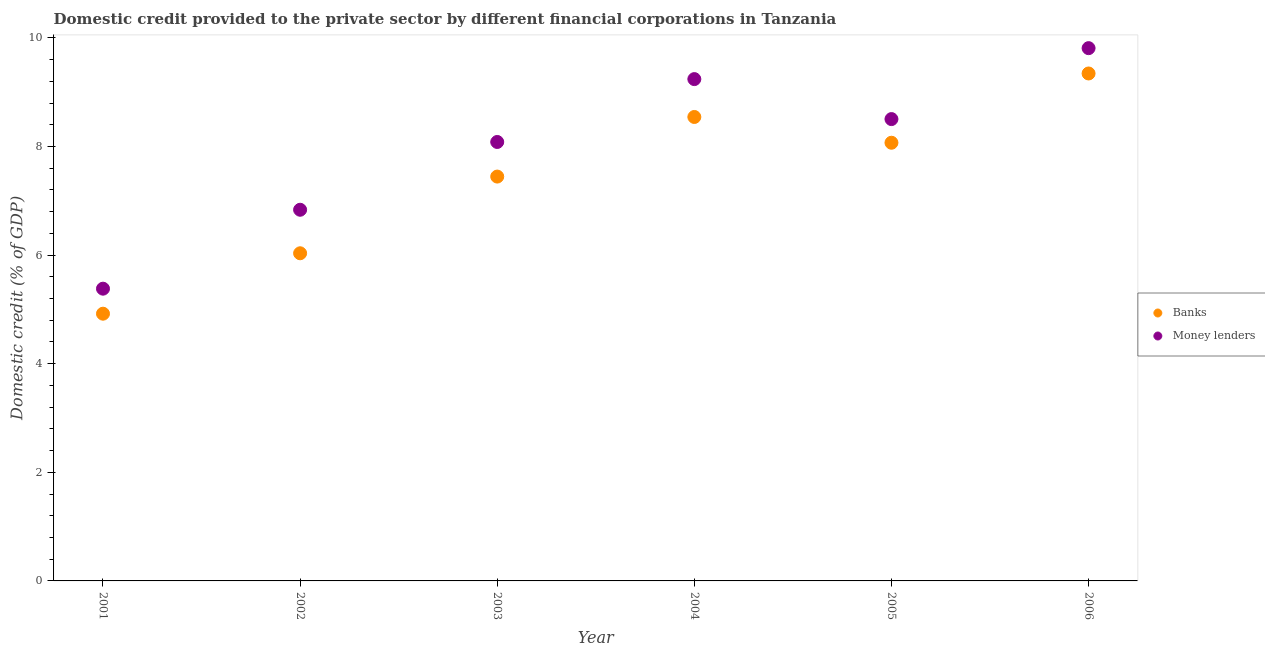What is the domestic credit provided by money lenders in 2001?
Provide a short and direct response. 5.38. Across all years, what is the maximum domestic credit provided by money lenders?
Your response must be concise. 9.81. Across all years, what is the minimum domestic credit provided by money lenders?
Your answer should be compact. 5.38. In which year was the domestic credit provided by banks maximum?
Provide a succinct answer. 2006. In which year was the domestic credit provided by banks minimum?
Provide a succinct answer. 2001. What is the total domestic credit provided by money lenders in the graph?
Give a very brief answer. 47.85. What is the difference between the domestic credit provided by banks in 2001 and that in 2002?
Your answer should be compact. -1.11. What is the difference between the domestic credit provided by money lenders in 2006 and the domestic credit provided by banks in 2005?
Your response must be concise. 1.74. What is the average domestic credit provided by money lenders per year?
Your answer should be compact. 7.98. In the year 2006, what is the difference between the domestic credit provided by banks and domestic credit provided by money lenders?
Offer a very short reply. -0.47. What is the ratio of the domestic credit provided by banks in 2004 to that in 2005?
Offer a very short reply. 1.06. What is the difference between the highest and the second highest domestic credit provided by banks?
Ensure brevity in your answer.  0.8. What is the difference between the highest and the lowest domestic credit provided by banks?
Your answer should be very brief. 4.42. In how many years, is the domestic credit provided by banks greater than the average domestic credit provided by banks taken over all years?
Offer a terse response. 4. Is the sum of the domestic credit provided by money lenders in 2002 and 2003 greater than the maximum domestic credit provided by banks across all years?
Provide a succinct answer. Yes. Does the domestic credit provided by banks monotonically increase over the years?
Offer a very short reply. No. Is the domestic credit provided by money lenders strictly greater than the domestic credit provided by banks over the years?
Your response must be concise. Yes. Are the values on the major ticks of Y-axis written in scientific E-notation?
Provide a short and direct response. No. Does the graph contain any zero values?
Offer a very short reply. No. What is the title of the graph?
Give a very brief answer. Domestic credit provided to the private sector by different financial corporations in Tanzania. What is the label or title of the Y-axis?
Provide a succinct answer. Domestic credit (% of GDP). What is the Domestic credit (% of GDP) of Banks in 2001?
Give a very brief answer. 4.92. What is the Domestic credit (% of GDP) of Money lenders in 2001?
Offer a terse response. 5.38. What is the Domestic credit (% of GDP) in Banks in 2002?
Make the answer very short. 6.03. What is the Domestic credit (% of GDP) in Money lenders in 2002?
Your answer should be compact. 6.83. What is the Domestic credit (% of GDP) of Banks in 2003?
Give a very brief answer. 7.45. What is the Domestic credit (% of GDP) in Money lenders in 2003?
Offer a terse response. 8.08. What is the Domestic credit (% of GDP) of Banks in 2004?
Provide a succinct answer. 8.54. What is the Domestic credit (% of GDP) in Money lenders in 2004?
Keep it short and to the point. 9.24. What is the Domestic credit (% of GDP) of Banks in 2005?
Your response must be concise. 8.07. What is the Domestic credit (% of GDP) in Money lenders in 2005?
Provide a short and direct response. 8.5. What is the Domestic credit (% of GDP) in Banks in 2006?
Your response must be concise. 9.34. What is the Domestic credit (% of GDP) of Money lenders in 2006?
Make the answer very short. 9.81. Across all years, what is the maximum Domestic credit (% of GDP) in Banks?
Provide a succinct answer. 9.34. Across all years, what is the maximum Domestic credit (% of GDP) in Money lenders?
Ensure brevity in your answer.  9.81. Across all years, what is the minimum Domestic credit (% of GDP) of Banks?
Your answer should be compact. 4.92. Across all years, what is the minimum Domestic credit (% of GDP) in Money lenders?
Provide a succinct answer. 5.38. What is the total Domestic credit (% of GDP) of Banks in the graph?
Offer a terse response. 44.36. What is the total Domestic credit (% of GDP) in Money lenders in the graph?
Offer a very short reply. 47.85. What is the difference between the Domestic credit (% of GDP) of Banks in 2001 and that in 2002?
Your answer should be compact. -1.11. What is the difference between the Domestic credit (% of GDP) of Money lenders in 2001 and that in 2002?
Offer a very short reply. -1.45. What is the difference between the Domestic credit (% of GDP) in Banks in 2001 and that in 2003?
Offer a very short reply. -2.52. What is the difference between the Domestic credit (% of GDP) in Money lenders in 2001 and that in 2003?
Your answer should be compact. -2.7. What is the difference between the Domestic credit (% of GDP) in Banks in 2001 and that in 2004?
Offer a terse response. -3.62. What is the difference between the Domestic credit (% of GDP) of Money lenders in 2001 and that in 2004?
Keep it short and to the point. -3.86. What is the difference between the Domestic credit (% of GDP) of Banks in 2001 and that in 2005?
Your answer should be very brief. -3.15. What is the difference between the Domestic credit (% of GDP) of Money lenders in 2001 and that in 2005?
Make the answer very short. -3.12. What is the difference between the Domestic credit (% of GDP) in Banks in 2001 and that in 2006?
Provide a short and direct response. -4.42. What is the difference between the Domestic credit (% of GDP) of Money lenders in 2001 and that in 2006?
Your answer should be very brief. -4.43. What is the difference between the Domestic credit (% of GDP) in Banks in 2002 and that in 2003?
Provide a succinct answer. -1.41. What is the difference between the Domestic credit (% of GDP) in Money lenders in 2002 and that in 2003?
Give a very brief answer. -1.25. What is the difference between the Domestic credit (% of GDP) in Banks in 2002 and that in 2004?
Your response must be concise. -2.51. What is the difference between the Domestic credit (% of GDP) of Money lenders in 2002 and that in 2004?
Make the answer very short. -2.41. What is the difference between the Domestic credit (% of GDP) in Banks in 2002 and that in 2005?
Keep it short and to the point. -2.04. What is the difference between the Domestic credit (% of GDP) in Money lenders in 2002 and that in 2005?
Offer a terse response. -1.67. What is the difference between the Domestic credit (% of GDP) of Banks in 2002 and that in 2006?
Your answer should be compact. -3.31. What is the difference between the Domestic credit (% of GDP) in Money lenders in 2002 and that in 2006?
Offer a terse response. -2.98. What is the difference between the Domestic credit (% of GDP) in Banks in 2003 and that in 2004?
Provide a short and direct response. -1.1. What is the difference between the Domestic credit (% of GDP) of Money lenders in 2003 and that in 2004?
Provide a short and direct response. -1.16. What is the difference between the Domestic credit (% of GDP) of Banks in 2003 and that in 2005?
Offer a very short reply. -0.62. What is the difference between the Domestic credit (% of GDP) of Money lenders in 2003 and that in 2005?
Your answer should be very brief. -0.42. What is the difference between the Domestic credit (% of GDP) of Banks in 2003 and that in 2006?
Your answer should be compact. -1.9. What is the difference between the Domestic credit (% of GDP) in Money lenders in 2003 and that in 2006?
Your response must be concise. -1.73. What is the difference between the Domestic credit (% of GDP) in Banks in 2004 and that in 2005?
Your answer should be compact. 0.47. What is the difference between the Domestic credit (% of GDP) in Money lenders in 2004 and that in 2005?
Your answer should be very brief. 0.74. What is the difference between the Domestic credit (% of GDP) of Banks in 2004 and that in 2006?
Provide a succinct answer. -0.8. What is the difference between the Domestic credit (% of GDP) in Money lenders in 2004 and that in 2006?
Your answer should be very brief. -0.57. What is the difference between the Domestic credit (% of GDP) of Banks in 2005 and that in 2006?
Your answer should be compact. -1.28. What is the difference between the Domestic credit (% of GDP) in Money lenders in 2005 and that in 2006?
Ensure brevity in your answer.  -1.31. What is the difference between the Domestic credit (% of GDP) of Banks in 2001 and the Domestic credit (% of GDP) of Money lenders in 2002?
Offer a terse response. -1.91. What is the difference between the Domestic credit (% of GDP) of Banks in 2001 and the Domestic credit (% of GDP) of Money lenders in 2003?
Offer a terse response. -3.16. What is the difference between the Domestic credit (% of GDP) in Banks in 2001 and the Domestic credit (% of GDP) in Money lenders in 2004?
Give a very brief answer. -4.32. What is the difference between the Domestic credit (% of GDP) in Banks in 2001 and the Domestic credit (% of GDP) in Money lenders in 2005?
Ensure brevity in your answer.  -3.58. What is the difference between the Domestic credit (% of GDP) of Banks in 2001 and the Domestic credit (% of GDP) of Money lenders in 2006?
Your answer should be compact. -4.89. What is the difference between the Domestic credit (% of GDP) of Banks in 2002 and the Domestic credit (% of GDP) of Money lenders in 2003?
Provide a short and direct response. -2.05. What is the difference between the Domestic credit (% of GDP) in Banks in 2002 and the Domestic credit (% of GDP) in Money lenders in 2004?
Make the answer very short. -3.21. What is the difference between the Domestic credit (% of GDP) in Banks in 2002 and the Domestic credit (% of GDP) in Money lenders in 2005?
Give a very brief answer. -2.47. What is the difference between the Domestic credit (% of GDP) in Banks in 2002 and the Domestic credit (% of GDP) in Money lenders in 2006?
Your response must be concise. -3.78. What is the difference between the Domestic credit (% of GDP) in Banks in 2003 and the Domestic credit (% of GDP) in Money lenders in 2004?
Keep it short and to the point. -1.79. What is the difference between the Domestic credit (% of GDP) in Banks in 2003 and the Domestic credit (% of GDP) in Money lenders in 2005?
Your answer should be compact. -1.06. What is the difference between the Domestic credit (% of GDP) in Banks in 2003 and the Domestic credit (% of GDP) in Money lenders in 2006?
Offer a terse response. -2.36. What is the difference between the Domestic credit (% of GDP) of Banks in 2004 and the Domestic credit (% of GDP) of Money lenders in 2005?
Give a very brief answer. 0.04. What is the difference between the Domestic credit (% of GDP) in Banks in 2004 and the Domestic credit (% of GDP) in Money lenders in 2006?
Ensure brevity in your answer.  -1.27. What is the difference between the Domestic credit (% of GDP) in Banks in 2005 and the Domestic credit (% of GDP) in Money lenders in 2006?
Give a very brief answer. -1.74. What is the average Domestic credit (% of GDP) in Banks per year?
Offer a terse response. 7.39. What is the average Domestic credit (% of GDP) in Money lenders per year?
Offer a terse response. 7.98. In the year 2001, what is the difference between the Domestic credit (% of GDP) of Banks and Domestic credit (% of GDP) of Money lenders?
Ensure brevity in your answer.  -0.46. In the year 2002, what is the difference between the Domestic credit (% of GDP) of Banks and Domestic credit (% of GDP) of Money lenders?
Keep it short and to the point. -0.8. In the year 2003, what is the difference between the Domestic credit (% of GDP) of Banks and Domestic credit (% of GDP) of Money lenders?
Your answer should be compact. -0.64. In the year 2004, what is the difference between the Domestic credit (% of GDP) in Banks and Domestic credit (% of GDP) in Money lenders?
Offer a terse response. -0.7. In the year 2005, what is the difference between the Domestic credit (% of GDP) in Banks and Domestic credit (% of GDP) in Money lenders?
Ensure brevity in your answer.  -0.44. In the year 2006, what is the difference between the Domestic credit (% of GDP) in Banks and Domestic credit (% of GDP) in Money lenders?
Offer a terse response. -0.47. What is the ratio of the Domestic credit (% of GDP) in Banks in 2001 to that in 2002?
Keep it short and to the point. 0.82. What is the ratio of the Domestic credit (% of GDP) in Money lenders in 2001 to that in 2002?
Keep it short and to the point. 0.79. What is the ratio of the Domestic credit (% of GDP) in Banks in 2001 to that in 2003?
Offer a very short reply. 0.66. What is the ratio of the Domestic credit (% of GDP) in Money lenders in 2001 to that in 2003?
Give a very brief answer. 0.67. What is the ratio of the Domestic credit (% of GDP) of Banks in 2001 to that in 2004?
Offer a very short reply. 0.58. What is the ratio of the Domestic credit (% of GDP) of Money lenders in 2001 to that in 2004?
Offer a terse response. 0.58. What is the ratio of the Domestic credit (% of GDP) of Banks in 2001 to that in 2005?
Your response must be concise. 0.61. What is the ratio of the Domestic credit (% of GDP) in Money lenders in 2001 to that in 2005?
Your answer should be compact. 0.63. What is the ratio of the Domestic credit (% of GDP) in Banks in 2001 to that in 2006?
Your answer should be very brief. 0.53. What is the ratio of the Domestic credit (% of GDP) of Money lenders in 2001 to that in 2006?
Your response must be concise. 0.55. What is the ratio of the Domestic credit (% of GDP) in Banks in 2002 to that in 2003?
Provide a short and direct response. 0.81. What is the ratio of the Domestic credit (% of GDP) in Money lenders in 2002 to that in 2003?
Provide a short and direct response. 0.85. What is the ratio of the Domestic credit (% of GDP) in Banks in 2002 to that in 2004?
Make the answer very short. 0.71. What is the ratio of the Domestic credit (% of GDP) of Money lenders in 2002 to that in 2004?
Your answer should be very brief. 0.74. What is the ratio of the Domestic credit (% of GDP) in Banks in 2002 to that in 2005?
Your response must be concise. 0.75. What is the ratio of the Domestic credit (% of GDP) of Money lenders in 2002 to that in 2005?
Ensure brevity in your answer.  0.8. What is the ratio of the Domestic credit (% of GDP) in Banks in 2002 to that in 2006?
Provide a short and direct response. 0.65. What is the ratio of the Domestic credit (% of GDP) of Money lenders in 2002 to that in 2006?
Offer a very short reply. 0.7. What is the ratio of the Domestic credit (% of GDP) of Banks in 2003 to that in 2004?
Provide a succinct answer. 0.87. What is the ratio of the Domestic credit (% of GDP) of Money lenders in 2003 to that in 2004?
Offer a terse response. 0.87. What is the ratio of the Domestic credit (% of GDP) of Banks in 2003 to that in 2005?
Provide a short and direct response. 0.92. What is the ratio of the Domestic credit (% of GDP) of Money lenders in 2003 to that in 2005?
Provide a short and direct response. 0.95. What is the ratio of the Domestic credit (% of GDP) of Banks in 2003 to that in 2006?
Give a very brief answer. 0.8. What is the ratio of the Domestic credit (% of GDP) of Money lenders in 2003 to that in 2006?
Provide a succinct answer. 0.82. What is the ratio of the Domestic credit (% of GDP) of Banks in 2004 to that in 2005?
Keep it short and to the point. 1.06. What is the ratio of the Domestic credit (% of GDP) of Money lenders in 2004 to that in 2005?
Make the answer very short. 1.09. What is the ratio of the Domestic credit (% of GDP) in Banks in 2004 to that in 2006?
Offer a terse response. 0.91. What is the ratio of the Domestic credit (% of GDP) in Money lenders in 2004 to that in 2006?
Provide a succinct answer. 0.94. What is the ratio of the Domestic credit (% of GDP) in Banks in 2005 to that in 2006?
Give a very brief answer. 0.86. What is the ratio of the Domestic credit (% of GDP) of Money lenders in 2005 to that in 2006?
Ensure brevity in your answer.  0.87. What is the difference between the highest and the second highest Domestic credit (% of GDP) of Banks?
Offer a very short reply. 0.8. What is the difference between the highest and the second highest Domestic credit (% of GDP) in Money lenders?
Ensure brevity in your answer.  0.57. What is the difference between the highest and the lowest Domestic credit (% of GDP) of Banks?
Provide a short and direct response. 4.42. What is the difference between the highest and the lowest Domestic credit (% of GDP) in Money lenders?
Keep it short and to the point. 4.43. 